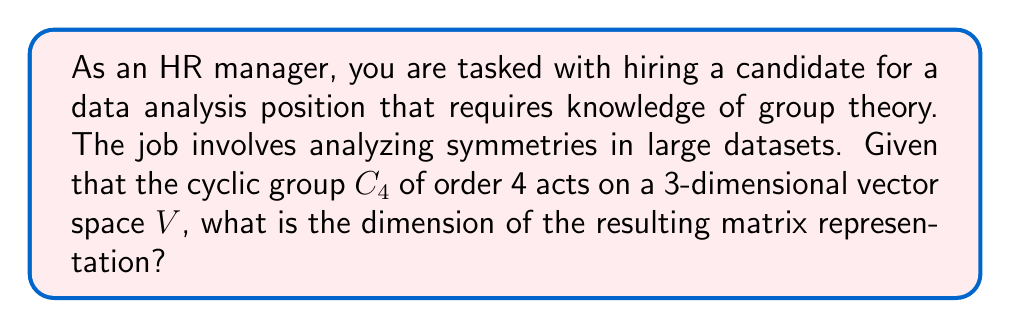Can you solve this math problem? To determine the dimension of the matrix representation, we follow these steps:

1) In a matrix representation, each element of the group is represented by a square matrix.

2) The dimension of these matrices is equal to the dimension of the vector space on which the group acts.

3) In this case, the group $C_4$ acts on a 3-dimensional vector space $V$.

4) Therefore, each element of $C_4$ will be represented by a 3x3 matrix.

5) The dimension of a 3x3 matrix is 3.

6) Thus, the dimension of the matrix representation is 3.

This knowledge is relevant for data analysis positions as it helps in understanding how symmetries in datasets can be represented and manipulated mathematically.
Answer: 3 